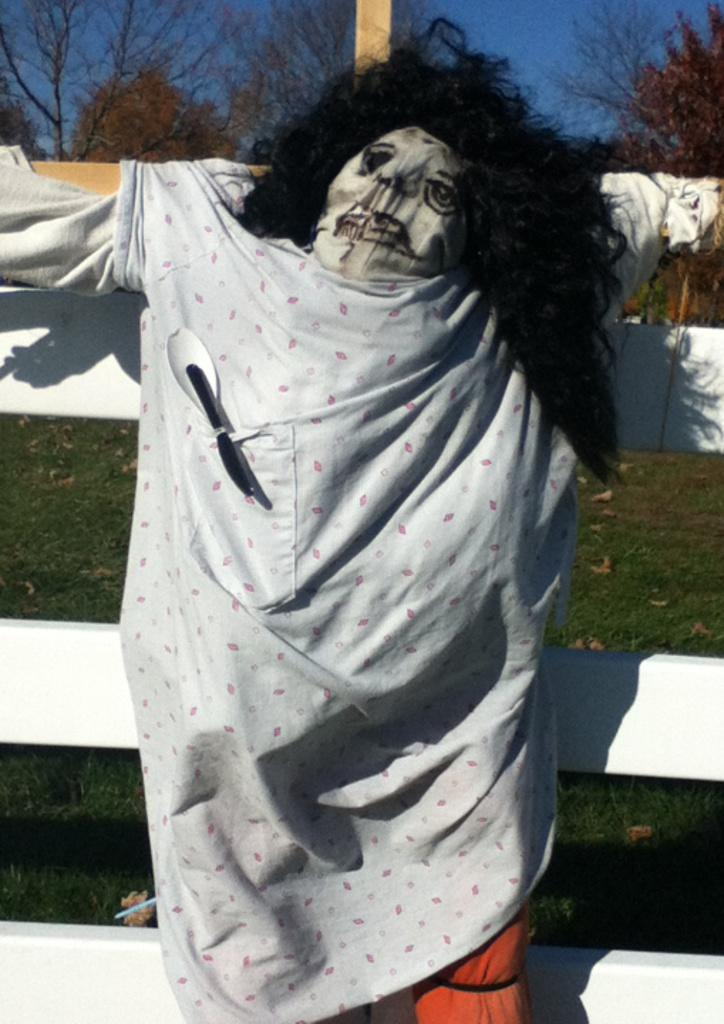What is the main subject in the middle of the image? There is a scarecrow in the middle of the image. What can be seen in the background of the image? There are trees in the background of the image. What type of agreement is the scarecrow holding in the image? There is no agreement visible in the image; the scarecrow is not holding any object. 